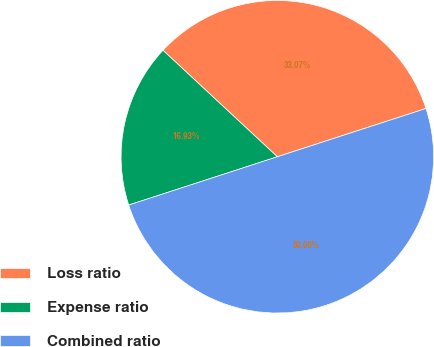Convert chart. <chart><loc_0><loc_0><loc_500><loc_500><pie_chart><fcel>Loss ratio<fcel>Expense ratio<fcel>Combined ratio<nl><fcel>33.07%<fcel>16.93%<fcel>50.0%<nl></chart> 